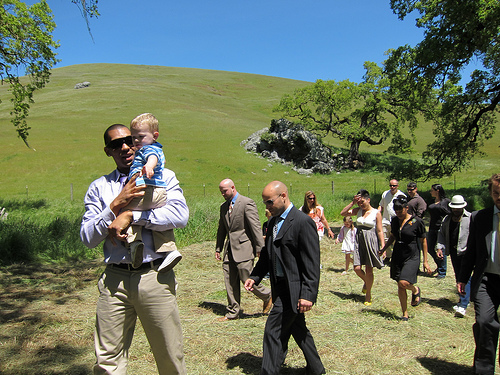<image>
Is the child on the ground? No. The child is not positioned on the ground. They may be near each other, but the child is not supported by or resting on top of the ground. Is the women behind the man? Yes. From this viewpoint, the women is positioned behind the man, with the man partially or fully occluding the women. 